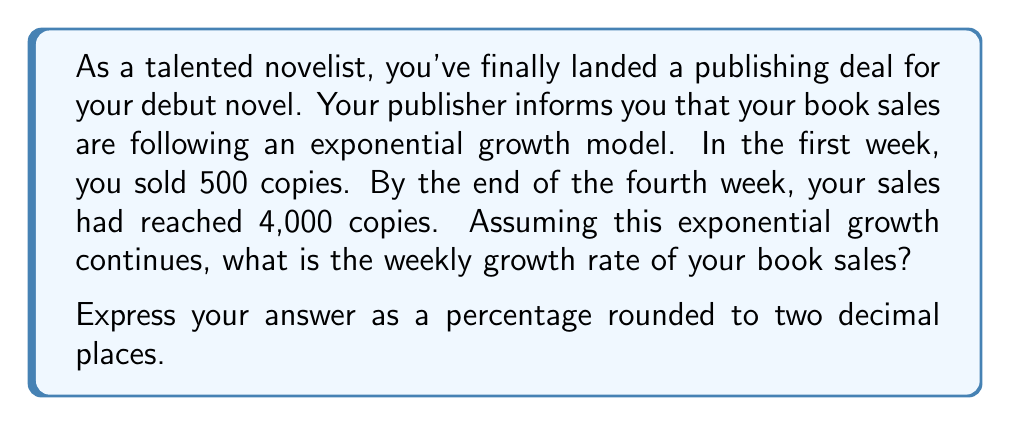Can you solve this math problem? Let's approach this step-by-step using the exponential growth formula:

$$A = P(1 + r)^t$$

Where:
$A$ is the final amount
$P$ is the initial amount
$r$ is the growth rate (in decimal form)
$t$ is the time period

We know:
$P = 500$ (initial sales in week 1)
$A = 4000$ (sales by end of week 4)
$t = 3$ (3 weeks of growth from week 1 to week 4)

Let's plug these into our formula:

$$4000 = 500(1 + r)^3$$

Now, let's solve for $r$:

1) Divide both sides by 500:
   $$8 = (1 + r)^3$$

2) Take the cube root of both sides:
   $$\sqrt[3]{8} = 1 + r$$

3) Simplify:
   $$2 = 1 + r$$

4) Subtract 1 from both sides:
   $$1 = r$$

5) Convert to a percentage:
   $$r = 1 * 100\% = 100\%$$

Therefore, the weekly growth rate is 100%.
Answer: 100.00% 